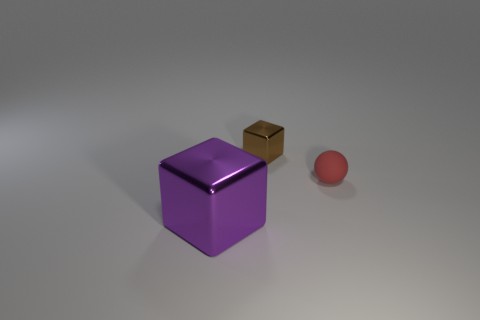Are the tiny thing that is in front of the brown shiny cube and the tiny brown thing made of the same material? Although it's not entirely possible to determine the composition of objects in an image with certainty, the texture and appearance suggest they might be made from different materials. The tiny object in front of the brown cube appears to have a smooth, possibly metallic finish, while the brown cube seems to have a matte, wood-like texture. 